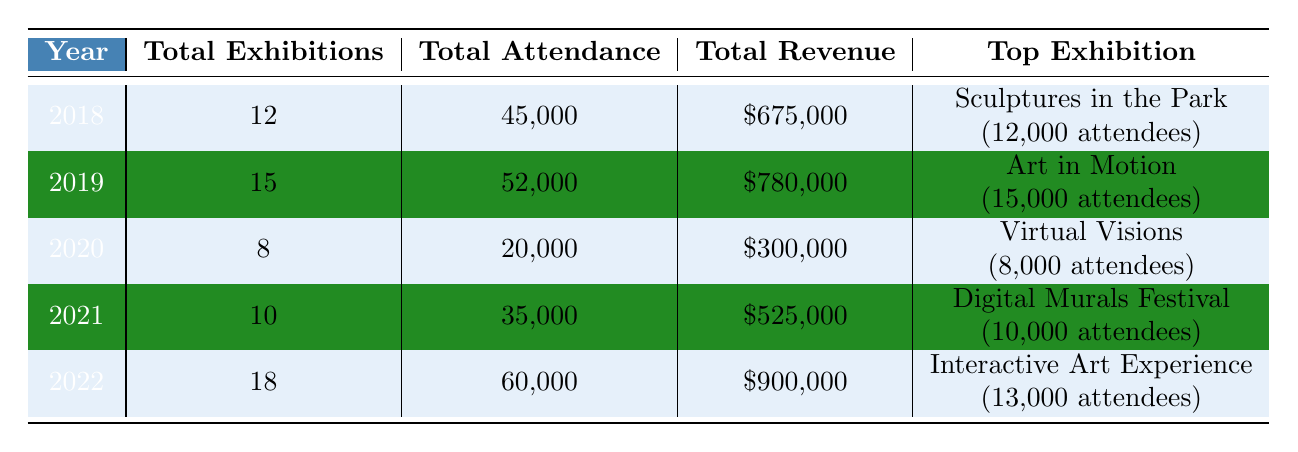What was the total revenue generated in 2021? In the 2021 row of the table, the total revenue is clearly indicated as $525,000.
Answer: $525,000 Which year had the highest total attendance? By comparing the total attendance figures across all years, 2022 has the highest total attendance at 60,000.
Answer: 2022 What was the average number of total exhibitions from 2018 to 2022? To find the average, sum the total exhibitions: (12 + 15 + 8 + 10 + 18) = 63 and divide by the number of years (5), so 63/5 = 12.6.
Answer: 12.6 Was "Digital Murals Festival" in 2021 the top exhibition that year? The top exhibition for 2021 is "Digital Murals Festival" with 10,000 attendees, but comparing it with 2018, 2019, and 2022, it does not exceed their top exhibitions, which had more attendees. Therefore, while it tops its own year, it isn't the highest overall.
Answer: No What is the difference in total revenue between the years 2019 and 2022? Total revenue for 2019 is $780,000 and for 2022 it is $900,000. The difference is $900,000 - $780,000 = $120,000.
Answer: $120,000 What venue hosted the top exhibition in 2020? The top exhibition in 2020 was "Virtual Visions," which was held on an online platform.
Answer: Online Platform How many total featured artists were in the exhibitions for 2020? For 2020, the exhibitions feature: 25 (Virtual Visions) + 30 (Pandemic Perspectives) + 15 (Outdoor Art Walk) = 70 featured artists in total.
Answer: 70 In which year did the city have fewer than 10 exhibitions? The only year with fewer than 10 exhibitions is 2020, where there were only 8 exhibitions.
Answer: 2020 What percentage of the total attendance in 2022 is the attendance of the "Interactive Art Experience"? The attendance of "Interactive Art Experience" is 13,000. To find the percentage, calculate (13,000 / 60,000) * 100 = 21.67%.
Answer: Approximately 21.67% What was the total revenue from the "Sculptures in the Park" exhibition? The revenue for the "Sculptures in the Park" exhibition, which took place in 2018, is listed as $180,000.
Answer: $180,000 